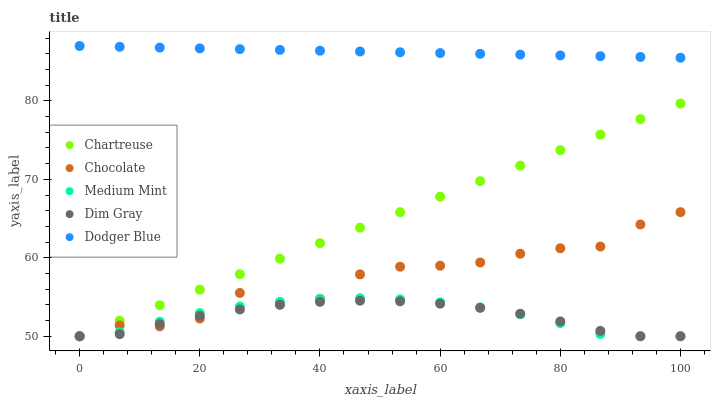Does Dim Gray have the minimum area under the curve?
Answer yes or no. Yes. Does Dodger Blue have the maximum area under the curve?
Answer yes or no. Yes. Does Chartreuse have the minimum area under the curve?
Answer yes or no. No. Does Chartreuse have the maximum area under the curve?
Answer yes or no. No. Is Dodger Blue the smoothest?
Answer yes or no. Yes. Is Chocolate the roughest?
Answer yes or no. Yes. Is Chartreuse the smoothest?
Answer yes or no. No. Is Chartreuse the roughest?
Answer yes or no. No. Does Medium Mint have the lowest value?
Answer yes or no. Yes. Does Dodger Blue have the lowest value?
Answer yes or no. No. Does Dodger Blue have the highest value?
Answer yes or no. Yes. Does Chartreuse have the highest value?
Answer yes or no. No. Is Medium Mint less than Dodger Blue?
Answer yes or no. Yes. Is Dodger Blue greater than Chocolate?
Answer yes or no. Yes. Does Chartreuse intersect Dim Gray?
Answer yes or no. Yes. Is Chartreuse less than Dim Gray?
Answer yes or no. No. Is Chartreuse greater than Dim Gray?
Answer yes or no. No. Does Medium Mint intersect Dodger Blue?
Answer yes or no. No. 